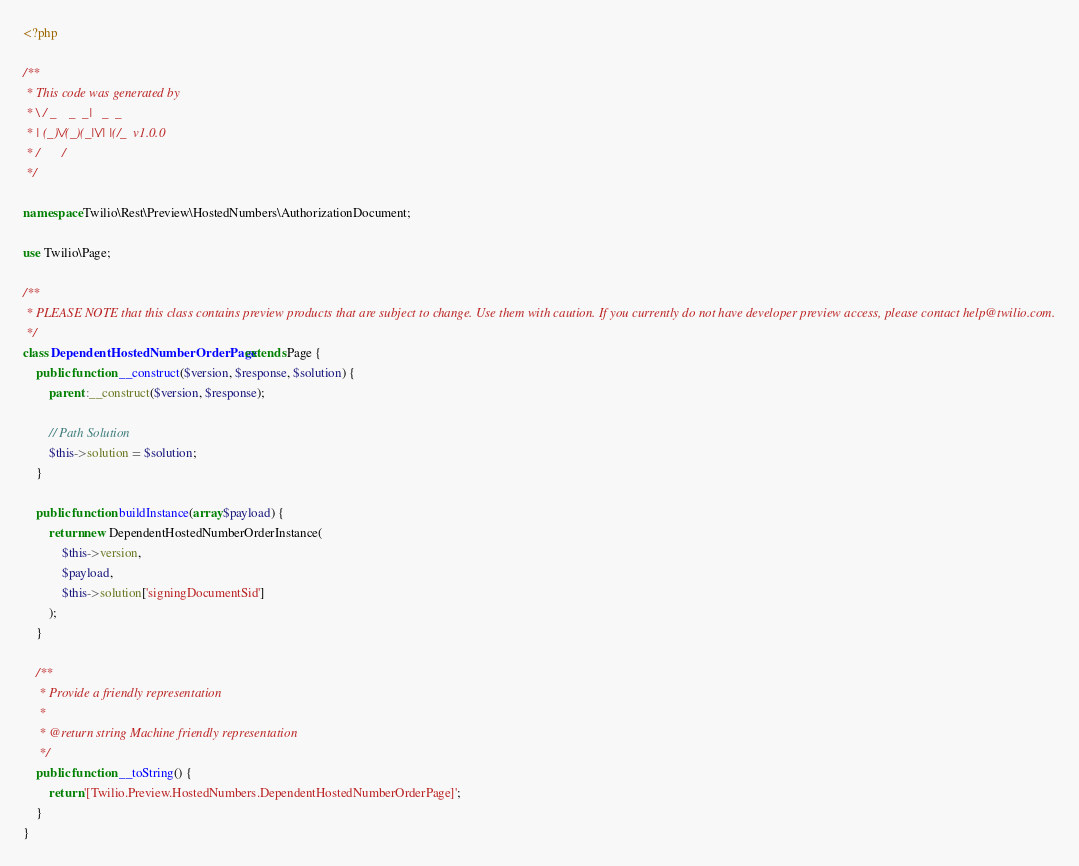<code> <loc_0><loc_0><loc_500><loc_500><_PHP_><?php

/**
 * This code was generated by
 * \ / _    _  _|   _  _
 * | (_)\/(_)(_|\/| |(/_  v1.0.0
 * /       /
 */

namespace Twilio\Rest\Preview\HostedNumbers\AuthorizationDocument;

use Twilio\Page;

/**
 * PLEASE NOTE that this class contains preview products that are subject to change. Use them with caution. If you currently do not have developer preview access, please contact help@twilio.com.
 */
class DependentHostedNumberOrderPage extends Page {
    public function __construct($version, $response, $solution) {
        parent::__construct($version, $response);

        // Path Solution
        $this->solution = $solution;
    }

    public function buildInstance(array $payload) {
        return new DependentHostedNumberOrderInstance(
            $this->version,
            $payload,
            $this->solution['signingDocumentSid']
        );
    }

    /**
     * Provide a friendly representation
     *
     * @return string Machine friendly representation
     */
    public function __toString() {
        return '[Twilio.Preview.HostedNumbers.DependentHostedNumberOrderPage]';
    }
}</code> 